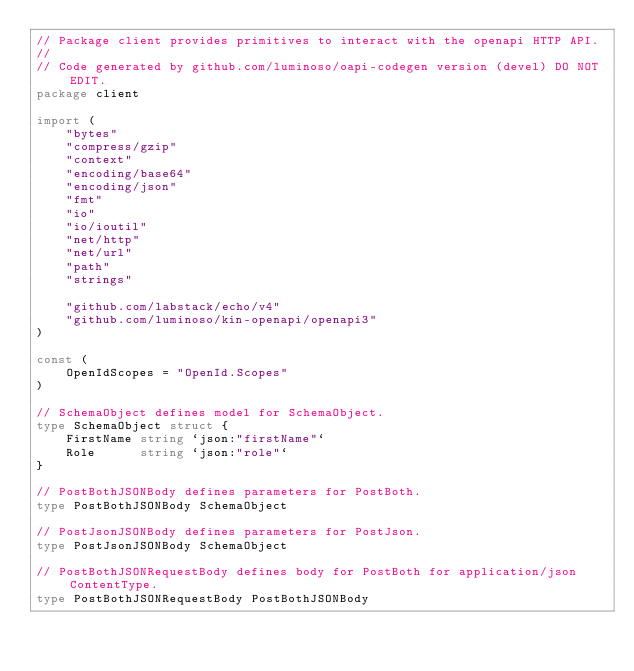<code> <loc_0><loc_0><loc_500><loc_500><_Go_>// Package client provides primitives to interact with the openapi HTTP API.
//
// Code generated by github.com/luminoso/oapi-codegen version (devel) DO NOT EDIT.
package client

import (
	"bytes"
	"compress/gzip"
	"context"
	"encoding/base64"
	"encoding/json"
	"fmt"
	"io"
	"io/ioutil"
	"net/http"
	"net/url"
	"path"
	"strings"

	"github.com/labstack/echo/v4"
	"github.com/luminoso/kin-openapi/openapi3"
)

const (
	OpenIdScopes = "OpenId.Scopes"
)

// SchemaObject defines model for SchemaObject.
type SchemaObject struct {
	FirstName string `json:"firstName"`
	Role      string `json:"role"`
}

// PostBothJSONBody defines parameters for PostBoth.
type PostBothJSONBody SchemaObject

// PostJsonJSONBody defines parameters for PostJson.
type PostJsonJSONBody SchemaObject

// PostBothJSONRequestBody defines body for PostBoth for application/json ContentType.
type PostBothJSONRequestBody PostBothJSONBody
</code> 